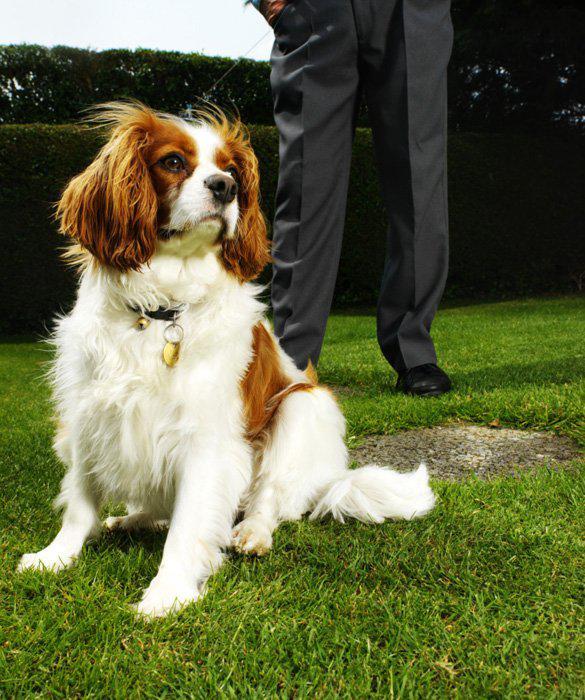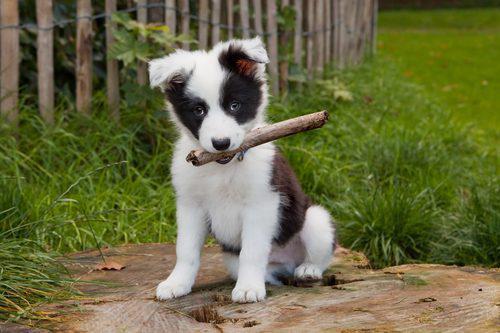The first image is the image on the left, the second image is the image on the right. Given the left and right images, does the statement "One dog is black with white on its legs and chest." hold true? Answer yes or no. No. The first image is the image on the left, the second image is the image on the right. Assess this claim about the two images: "At least one dog has its mouth open.". Correct or not? Answer yes or no. No. 